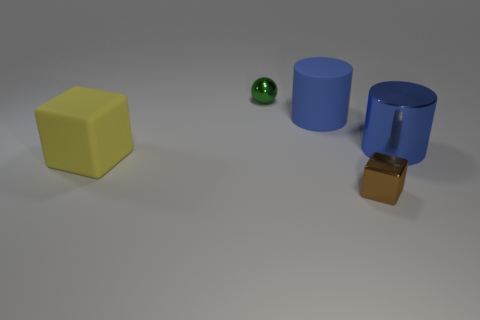Is the size of the cube that is to the right of the green thing the same as the tiny shiny ball?
Your answer should be compact. Yes. How many blue rubber objects are the same shape as the big blue metal thing?
Your response must be concise. 1. What size is the brown object that is the same material as the sphere?
Your answer should be very brief. Small. Is the number of large yellow objects in front of the small brown cube the same as the number of objects?
Keep it short and to the point. No. Do the big metallic thing and the matte cylinder have the same color?
Your answer should be compact. Yes. Do the thing behind the rubber cylinder and the tiny object that is in front of the ball have the same shape?
Your response must be concise. No. There is a brown object that is the same shape as the large yellow object; what material is it?
Ensure brevity in your answer.  Metal. What color is the metallic thing that is both to the right of the tiny green object and behind the small brown shiny block?
Ensure brevity in your answer.  Blue. Is there a sphere left of the tiny shiny thing that is in front of the large blue object to the left of the tiny cube?
Offer a very short reply. Yes. What number of objects are big yellow cubes or big blue cylinders?
Offer a terse response. 3. 